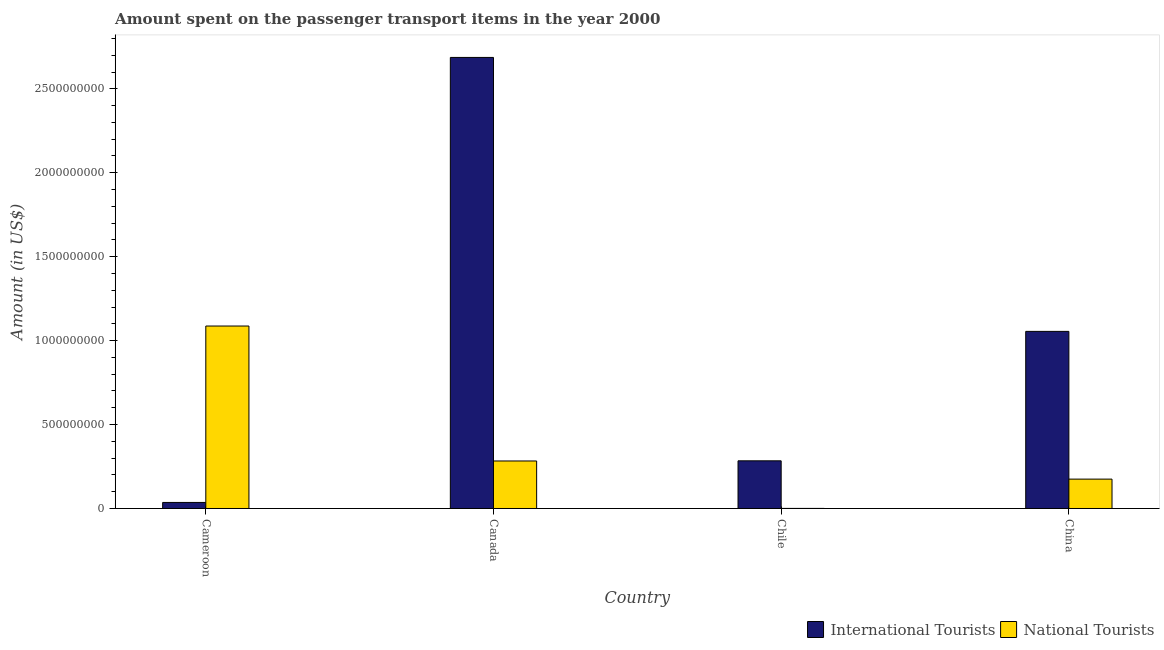How many different coloured bars are there?
Your answer should be very brief. 2. How many groups of bars are there?
Provide a succinct answer. 4. Are the number of bars per tick equal to the number of legend labels?
Ensure brevity in your answer.  Yes. Are the number of bars on each tick of the X-axis equal?
Your answer should be very brief. Yes. How many bars are there on the 4th tick from the right?
Your answer should be very brief. 2. What is the label of the 2nd group of bars from the left?
Your answer should be very brief. Canada. What is the amount spent on transport items of international tourists in Canada?
Make the answer very short. 2.69e+09. Across all countries, what is the maximum amount spent on transport items of national tourists?
Provide a succinct answer. 1.09e+09. Across all countries, what is the minimum amount spent on transport items of international tourists?
Provide a succinct answer. 3.60e+07. In which country was the amount spent on transport items of national tourists maximum?
Provide a short and direct response. Cameroon. In which country was the amount spent on transport items of international tourists minimum?
Give a very brief answer. Cameroon. What is the total amount spent on transport items of international tourists in the graph?
Give a very brief answer. 4.06e+09. What is the difference between the amount spent on transport items of international tourists in Cameroon and that in Canada?
Keep it short and to the point. -2.65e+09. What is the difference between the amount spent on transport items of national tourists in China and the amount spent on transport items of international tourists in Cameroon?
Give a very brief answer. 1.39e+08. What is the average amount spent on transport items of national tourists per country?
Make the answer very short. 3.86e+08. What is the difference between the amount spent on transport items of international tourists and amount spent on transport items of national tourists in China?
Keep it short and to the point. 8.80e+08. In how many countries, is the amount spent on transport items of national tourists greater than 2200000000 US$?
Make the answer very short. 0. What is the ratio of the amount spent on transport items of international tourists in Canada to that in China?
Your answer should be compact. 2.55. What is the difference between the highest and the second highest amount spent on transport items of international tourists?
Your response must be concise. 1.63e+09. What is the difference between the highest and the lowest amount spent on transport items of international tourists?
Ensure brevity in your answer.  2.65e+09. Is the sum of the amount spent on transport items of international tourists in Canada and China greater than the maximum amount spent on transport items of national tourists across all countries?
Offer a terse response. Yes. What does the 1st bar from the left in Chile represents?
Your response must be concise. International Tourists. What does the 2nd bar from the right in Chile represents?
Give a very brief answer. International Tourists. How many bars are there?
Provide a succinct answer. 8. Are all the bars in the graph horizontal?
Give a very brief answer. No. How many countries are there in the graph?
Provide a short and direct response. 4. What is the difference between two consecutive major ticks on the Y-axis?
Give a very brief answer. 5.00e+08. Where does the legend appear in the graph?
Your answer should be compact. Bottom right. How many legend labels are there?
Give a very brief answer. 2. How are the legend labels stacked?
Make the answer very short. Horizontal. What is the title of the graph?
Make the answer very short. Amount spent on the passenger transport items in the year 2000. What is the label or title of the Y-axis?
Ensure brevity in your answer.  Amount (in US$). What is the Amount (in US$) of International Tourists in Cameroon?
Provide a succinct answer. 3.60e+07. What is the Amount (in US$) of National Tourists in Cameroon?
Provide a succinct answer. 1.09e+09. What is the Amount (in US$) in International Tourists in Canada?
Make the answer very short. 2.69e+09. What is the Amount (in US$) of National Tourists in Canada?
Make the answer very short. 2.83e+08. What is the Amount (in US$) of International Tourists in Chile?
Provide a short and direct response. 2.84e+08. What is the Amount (in US$) of International Tourists in China?
Keep it short and to the point. 1.06e+09. What is the Amount (in US$) in National Tourists in China?
Your answer should be very brief. 1.75e+08. Across all countries, what is the maximum Amount (in US$) in International Tourists?
Ensure brevity in your answer.  2.69e+09. Across all countries, what is the maximum Amount (in US$) of National Tourists?
Ensure brevity in your answer.  1.09e+09. Across all countries, what is the minimum Amount (in US$) in International Tourists?
Keep it short and to the point. 3.60e+07. What is the total Amount (in US$) of International Tourists in the graph?
Make the answer very short. 4.06e+09. What is the total Amount (in US$) of National Tourists in the graph?
Ensure brevity in your answer.  1.55e+09. What is the difference between the Amount (in US$) of International Tourists in Cameroon and that in Canada?
Give a very brief answer. -2.65e+09. What is the difference between the Amount (in US$) in National Tourists in Cameroon and that in Canada?
Ensure brevity in your answer.  8.04e+08. What is the difference between the Amount (in US$) of International Tourists in Cameroon and that in Chile?
Give a very brief answer. -2.48e+08. What is the difference between the Amount (in US$) of National Tourists in Cameroon and that in Chile?
Provide a short and direct response. 1.09e+09. What is the difference between the Amount (in US$) of International Tourists in Cameroon and that in China?
Make the answer very short. -1.02e+09. What is the difference between the Amount (in US$) of National Tourists in Cameroon and that in China?
Provide a succinct answer. 9.12e+08. What is the difference between the Amount (in US$) of International Tourists in Canada and that in Chile?
Give a very brief answer. 2.40e+09. What is the difference between the Amount (in US$) in National Tourists in Canada and that in Chile?
Provide a short and direct response. 2.83e+08. What is the difference between the Amount (in US$) in International Tourists in Canada and that in China?
Your response must be concise. 1.63e+09. What is the difference between the Amount (in US$) in National Tourists in Canada and that in China?
Provide a succinct answer. 1.08e+08. What is the difference between the Amount (in US$) of International Tourists in Chile and that in China?
Provide a succinct answer. -7.71e+08. What is the difference between the Amount (in US$) in National Tourists in Chile and that in China?
Your answer should be compact. -1.75e+08. What is the difference between the Amount (in US$) of International Tourists in Cameroon and the Amount (in US$) of National Tourists in Canada?
Give a very brief answer. -2.47e+08. What is the difference between the Amount (in US$) of International Tourists in Cameroon and the Amount (in US$) of National Tourists in Chile?
Provide a succinct answer. 3.56e+07. What is the difference between the Amount (in US$) of International Tourists in Cameroon and the Amount (in US$) of National Tourists in China?
Provide a short and direct response. -1.39e+08. What is the difference between the Amount (in US$) in International Tourists in Canada and the Amount (in US$) in National Tourists in Chile?
Give a very brief answer. 2.69e+09. What is the difference between the Amount (in US$) in International Tourists in Canada and the Amount (in US$) in National Tourists in China?
Offer a very short reply. 2.51e+09. What is the difference between the Amount (in US$) of International Tourists in Chile and the Amount (in US$) of National Tourists in China?
Keep it short and to the point. 1.09e+08. What is the average Amount (in US$) in International Tourists per country?
Offer a terse response. 1.02e+09. What is the average Amount (in US$) of National Tourists per country?
Make the answer very short. 3.86e+08. What is the difference between the Amount (in US$) of International Tourists and Amount (in US$) of National Tourists in Cameroon?
Keep it short and to the point. -1.05e+09. What is the difference between the Amount (in US$) of International Tourists and Amount (in US$) of National Tourists in Canada?
Your response must be concise. 2.40e+09. What is the difference between the Amount (in US$) in International Tourists and Amount (in US$) in National Tourists in Chile?
Offer a terse response. 2.84e+08. What is the difference between the Amount (in US$) of International Tourists and Amount (in US$) of National Tourists in China?
Ensure brevity in your answer.  8.80e+08. What is the ratio of the Amount (in US$) of International Tourists in Cameroon to that in Canada?
Make the answer very short. 0.01. What is the ratio of the Amount (in US$) in National Tourists in Cameroon to that in Canada?
Provide a succinct answer. 3.84. What is the ratio of the Amount (in US$) in International Tourists in Cameroon to that in Chile?
Give a very brief answer. 0.13. What is the ratio of the Amount (in US$) in National Tourists in Cameroon to that in Chile?
Offer a terse response. 2717.5. What is the ratio of the Amount (in US$) in International Tourists in Cameroon to that in China?
Offer a terse response. 0.03. What is the ratio of the Amount (in US$) of National Tourists in Cameroon to that in China?
Your response must be concise. 6.21. What is the ratio of the Amount (in US$) of International Tourists in Canada to that in Chile?
Ensure brevity in your answer.  9.46. What is the ratio of the Amount (in US$) in National Tourists in Canada to that in Chile?
Keep it short and to the point. 707.5. What is the ratio of the Amount (in US$) of International Tourists in Canada to that in China?
Ensure brevity in your answer.  2.55. What is the ratio of the Amount (in US$) of National Tourists in Canada to that in China?
Keep it short and to the point. 1.62. What is the ratio of the Amount (in US$) in International Tourists in Chile to that in China?
Your answer should be compact. 0.27. What is the ratio of the Amount (in US$) in National Tourists in Chile to that in China?
Provide a short and direct response. 0. What is the difference between the highest and the second highest Amount (in US$) of International Tourists?
Offer a terse response. 1.63e+09. What is the difference between the highest and the second highest Amount (in US$) in National Tourists?
Offer a terse response. 8.04e+08. What is the difference between the highest and the lowest Amount (in US$) in International Tourists?
Provide a short and direct response. 2.65e+09. What is the difference between the highest and the lowest Amount (in US$) of National Tourists?
Keep it short and to the point. 1.09e+09. 